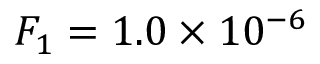<formula> <loc_0><loc_0><loc_500><loc_500>F _ { 1 } = 1 . 0 \times 1 0 ^ { - 6 }</formula> 